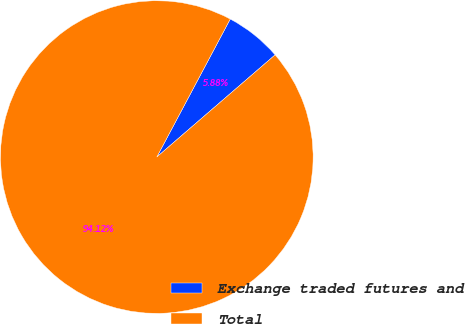Convert chart. <chart><loc_0><loc_0><loc_500><loc_500><pie_chart><fcel>Exchange traded futures and<fcel>Total<nl><fcel>5.88%<fcel>94.12%<nl></chart> 